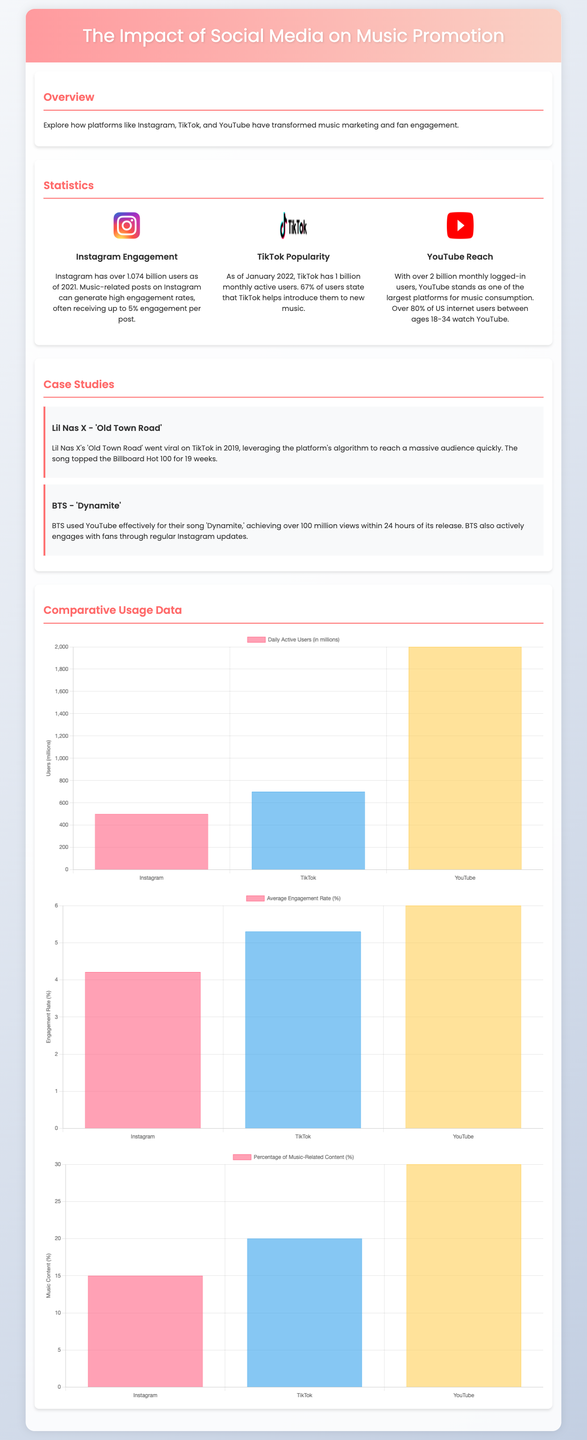What percentage of engagement do music-related posts on Instagram generate? The document states that music-related posts on Instagram can generate high engagement rates, often receiving up to 5% engagement per post.
Answer: 5% How many billion users does TikTok have as of January 2022? The statistics indicate that TikTok has 1 billion monthly active users as of January 2022.
Answer: 1 billion How many views did BTS achieve for 'Dynamite' within the first 24 hours on YouTube? The case study mentions that BTS achieved over 100 million views within 24 hours of its release for 'Dynamite'.
Answer: 100 million What is the average engagement rate for YouTube noted in the document? The engagement rate mentioned for YouTube is 6.00%.
Answer: 6.00% Which artist's song went viral on TikTok in 2019? The case study highlights Lil Nas X's song 'Old Town Road' as the one that went viral on TikTok.
Answer: Lil Nas X What is the total number of monthly logged-in users on YouTube? The document states that YouTube has over 2 billion monthly logged-in users.
Answer: 2 billion What color represents TikTok in the engagement chart? The document lists the colors used in the chart, and TikTok's representation color in the chart is the blue color.
Answer: blue How many percentage points is the engagement rate difference between Instagram and TikTok? The average engagement rates are given as 4.21% for Instagram and 5.30% for TikTok, making the difference 1.09%.
Answer: 1.09% 